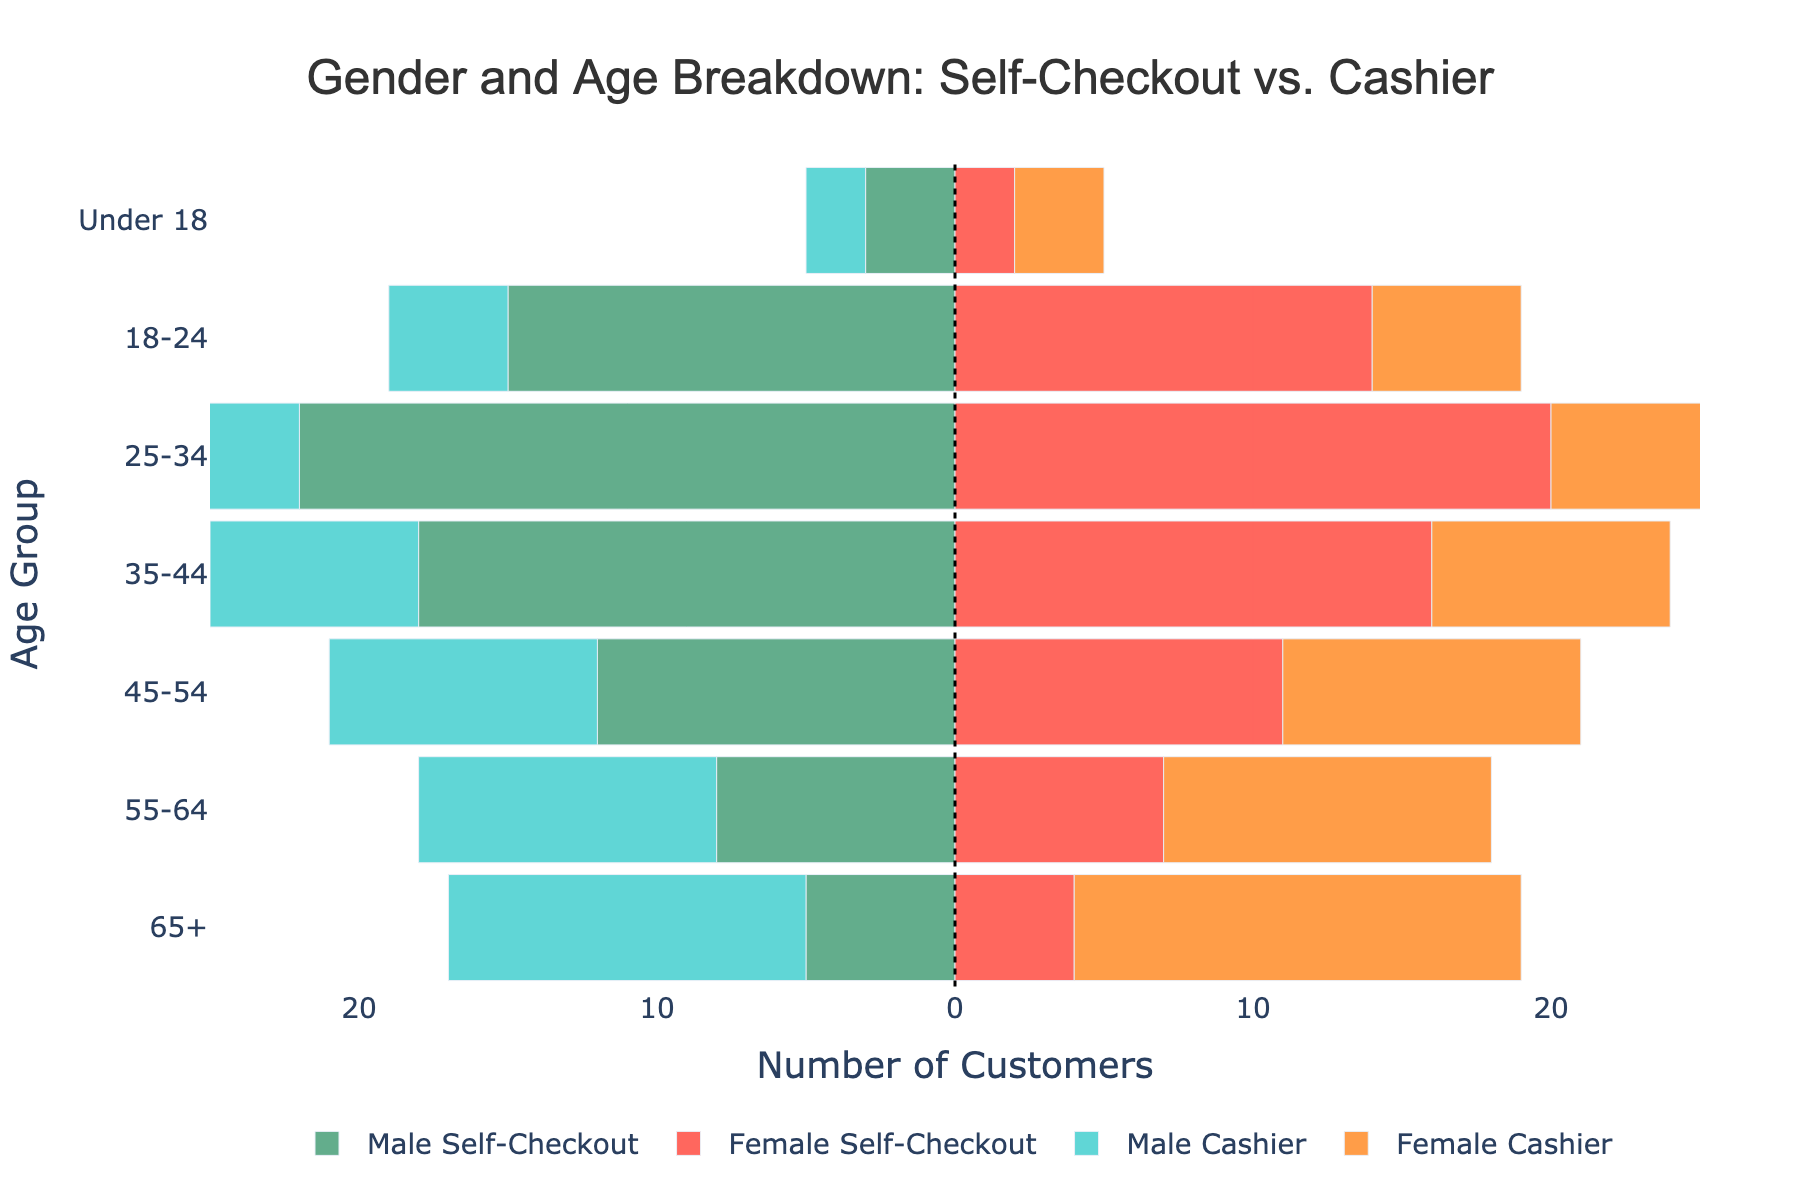Which age group has the highest number of male customers using self-checkout kiosks? According to the figure, the age group with the largest bar for 'Male Self-Checkout' is '25-34', indicating they have the highest number of male customers using self-checkout kiosks.
Answer: 25-34 Which age group has the largest number of female customers using traditional cashier lanes? The largest bar for 'Female Cashier' is in the '65+' age group, suggesting they have the highest number of female customers using traditional cashier lanes.
Answer: 65+ How do the number of male and female customers using self-checkout kiosks compare for the age group 35-44? For the age group '35-44', the number of male self-checkout customers is represented by the negative value of 18, while for females it's 16. Thus, there are slightly more males using self-checkout kiosks in this age group.
Answer: More males What is the difference in the number of female customers in the 18-24 age group between self-checkout kiosks and traditional cashier lanes? The figure shows 14 female self-checkout customers in the 18-24 age group and 5 female cashier customers in the same group. The difference is 14 - 5 = 9.
Answer: 9 In the '45-54' age group, which gender prefers traditional cashier lanes more, and by how much? By comparing the bars, the number of male customers using traditional cashiers is 9, and female customers are 10. Females prefer traditional cashier lanes in this age group by a margin of 10 - 9 = 1.
Answer: Females by 1 What general trend can be observed regarding the use of self-checkout kiosks by younger customers under the age of 35? By examining the figure, a general trend is that younger customers under the age of 35, both males, and females, tend to use self-checkout kiosks more frequently, as the lengths of these bars are significantly longer compared to those for traditional cashier lanes in these age groups.
Answer: Younger customers use self-checkout more What is the total number of customers in the '65+' age group who use traditional cashier lanes? The figure shows there are 12 males and 15 females in the '65+' age group using traditional cashier lanes. Adding these together gives 12 + 15 = 27.
Answer: 27 Which age group shows the least difference between the number of male and female customers using self-checkout kiosks? The smallest difference is observed in the '18-24' age group, where the number of male and female self-checkout customers are 15 and 14, respectively, making a difference of only 1.
Answer: 18-24 